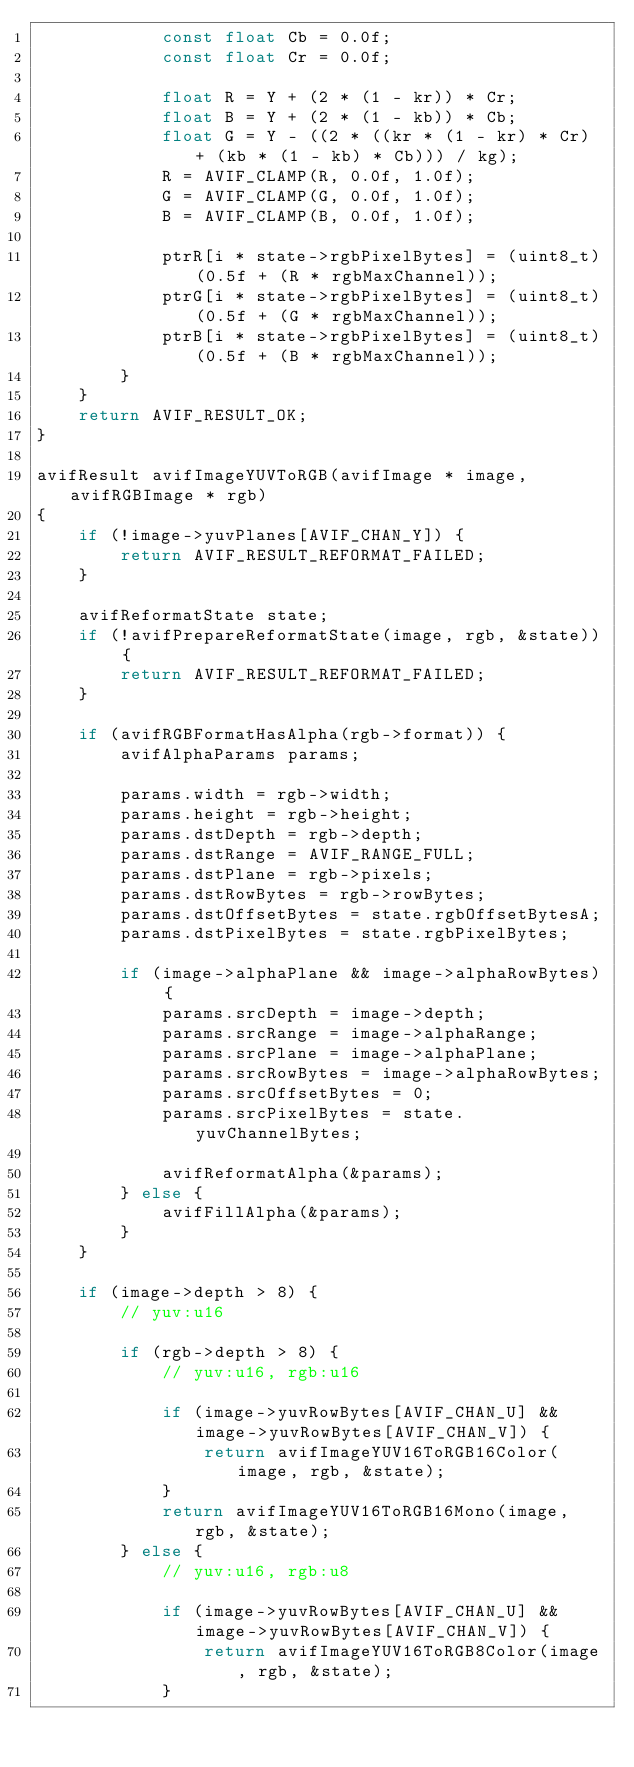Convert code to text. <code><loc_0><loc_0><loc_500><loc_500><_C_>            const float Cb = 0.0f;
            const float Cr = 0.0f;

            float R = Y + (2 * (1 - kr)) * Cr;
            float B = Y + (2 * (1 - kb)) * Cb;
            float G = Y - ((2 * ((kr * (1 - kr) * Cr) + (kb * (1 - kb) * Cb))) / kg);
            R = AVIF_CLAMP(R, 0.0f, 1.0f);
            G = AVIF_CLAMP(G, 0.0f, 1.0f);
            B = AVIF_CLAMP(B, 0.0f, 1.0f);

            ptrR[i * state->rgbPixelBytes] = (uint8_t)(0.5f + (R * rgbMaxChannel));
            ptrG[i * state->rgbPixelBytes] = (uint8_t)(0.5f + (G * rgbMaxChannel));
            ptrB[i * state->rgbPixelBytes] = (uint8_t)(0.5f + (B * rgbMaxChannel));
        }
    }
    return AVIF_RESULT_OK;
}

avifResult avifImageYUVToRGB(avifImage * image, avifRGBImage * rgb)
{
    if (!image->yuvPlanes[AVIF_CHAN_Y]) {
        return AVIF_RESULT_REFORMAT_FAILED;
    }

    avifReformatState state;
    if (!avifPrepareReformatState(image, rgb, &state)) {
        return AVIF_RESULT_REFORMAT_FAILED;
    }

    if (avifRGBFormatHasAlpha(rgb->format)) {
        avifAlphaParams params;

        params.width = rgb->width;
        params.height = rgb->height;
        params.dstDepth = rgb->depth;
        params.dstRange = AVIF_RANGE_FULL;
        params.dstPlane = rgb->pixels;
        params.dstRowBytes = rgb->rowBytes;
        params.dstOffsetBytes = state.rgbOffsetBytesA;
        params.dstPixelBytes = state.rgbPixelBytes;

        if (image->alphaPlane && image->alphaRowBytes) {
            params.srcDepth = image->depth;
            params.srcRange = image->alphaRange;
            params.srcPlane = image->alphaPlane;
            params.srcRowBytes = image->alphaRowBytes;
            params.srcOffsetBytes = 0;
            params.srcPixelBytes = state.yuvChannelBytes;

            avifReformatAlpha(&params);
        } else {
            avifFillAlpha(&params);
        }
    }

    if (image->depth > 8) {
        // yuv:u16

        if (rgb->depth > 8) {
            // yuv:u16, rgb:u16

            if (image->yuvRowBytes[AVIF_CHAN_U] && image->yuvRowBytes[AVIF_CHAN_V]) {
                return avifImageYUV16ToRGB16Color(image, rgb, &state);
            }
            return avifImageYUV16ToRGB16Mono(image, rgb, &state);
        } else {
            // yuv:u16, rgb:u8

            if (image->yuvRowBytes[AVIF_CHAN_U] && image->yuvRowBytes[AVIF_CHAN_V]) {
                return avifImageYUV16ToRGB8Color(image, rgb, &state);
            }</code> 